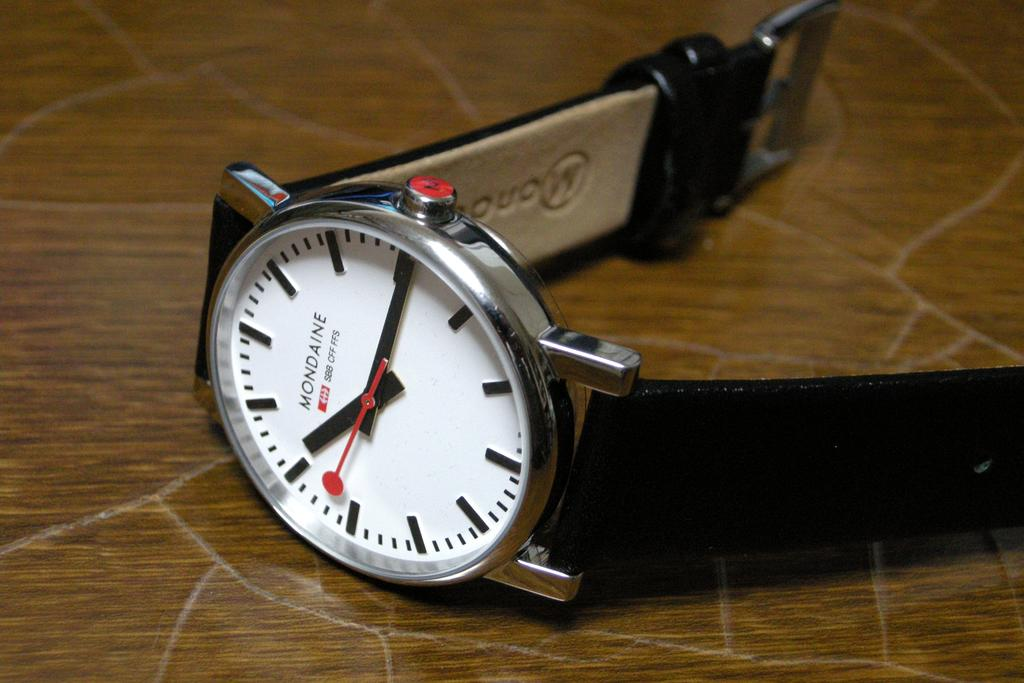<image>
Offer a succinct explanation of the picture presented. A watch is laying sideways on a table and it is a Mondaine watch. 